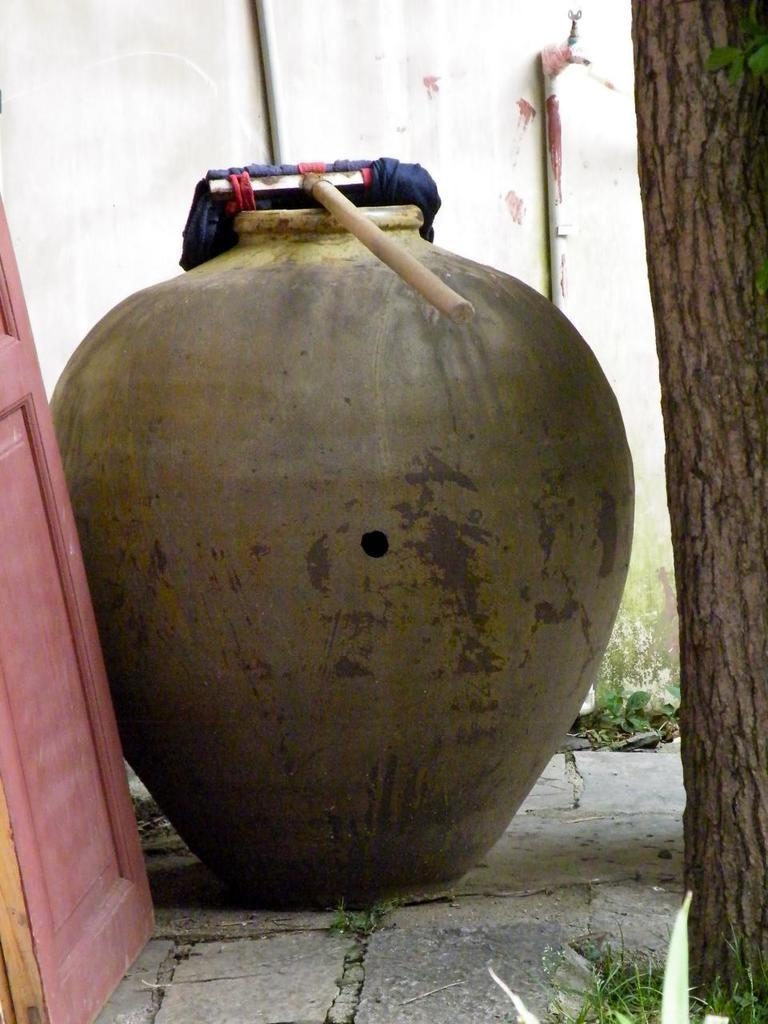What is the main object in the center of the image? There is a pot in the center of the image. What can be seen in the background of the image? There is a tree in the background of the image. What is used for water supply in the image? There is a tap visible in the image. What are the pipes used for in the image? Pipes are present in the image, likely for water supply or drainage. What object is present in the image that can be used for stirring or poking? There is a stick in the image. What structure is visible in the image that can be used for entering or exiting a room? There is a door in the image. What material is visible in the image that can be used for cleaning or covering? Cloth is visible in the image. What type of structure is present in the image that separates spaces? There is a wall in the image. What type of ball is being used for learning in the image? There is no ball or learning activity present in the image. 